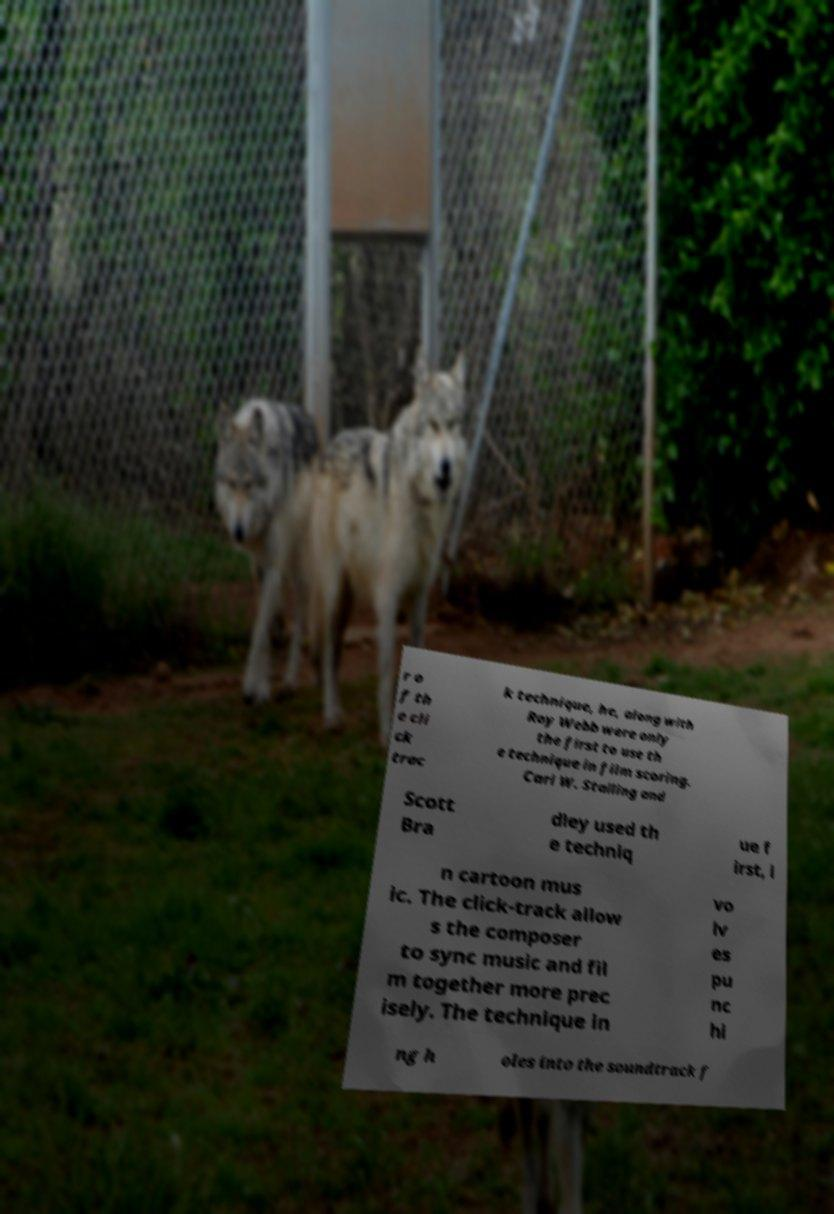Please identify and transcribe the text found in this image. r o f th e cli ck trac k technique, he, along with Roy Webb were only the first to use th e technique in film scoring. Carl W. Stalling and Scott Bra dley used th e techniq ue f irst, i n cartoon mus ic. The click-track allow s the composer to sync music and fil m together more prec isely. The technique in vo lv es pu nc hi ng h oles into the soundtrack f 